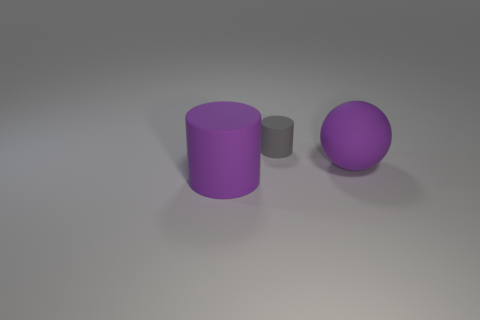There is a big purple matte object that is behind the large purple cylinder; is there a big purple cylinder that is behind it? No, there isn't a big purple cylinder behind the matte object. What we see in the image is a smaller gray cylinder positioned between a large purple cylinder and a large purple sphere. The large purple cylinder and the sphere are not directly behind one another; instead, they are arranged so that each object can be separately viewed. 